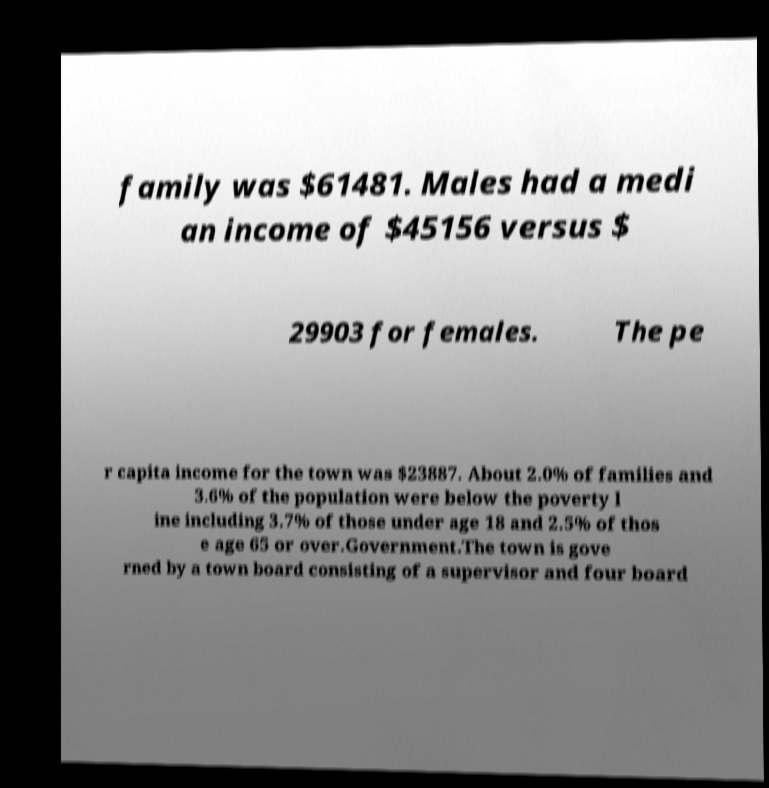I need the written content from this picture converted into text. Can you do that? family was $61481. Males had a medi an income of $45156 versus $ 29903 for females. The pe r capita income for the town was $23887. About 2.0% of families and 3.6% of the population were below the poverty l ine including 3.7% of those under age 18 and 2.5% of thos e age 65 or over.Government.The town is gove rned by a town board consisting of a supervisor and four board 